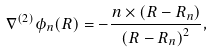Convert formula to latex. <formula><loc_0><loc_0><loc_500><loc_500>\nabla ^ { ( 2 ) } \phi _ { n } ( R ) = - \frac { n \times \left ( { R } - { R } _ { n } \right ) } { \left ( { R } - { R } _ { n } \right ) ^ { 2 } } ,</formula> 